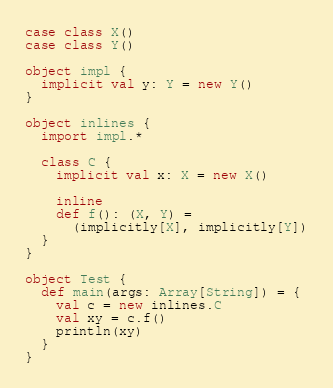<code> <loc_0><loc_0><loc_500><loc_500><_Scala_>case class X()
case class Y()

object impl {
  implicit val y: Y = new Y()
}

object inlines {
  import impl.*

  class C {
    implicit val x: X = new X()

    inline
    def f(): (X, Y) =
      (implicitly[X], implicitly[Y])
  }
}

object Test {
  def main(args: Array[String]) = {
    val c = new inlines.C
    val xy = c.f()
    println(xy)
  }
}
</code> 